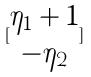<formula> <loc_0><loc_0><loc_500><loc_500>[ \begin{matrix} \eta _ { 1 } + 1 \\ - \eta _ { 2 } \end{matrix} ]</formula> 